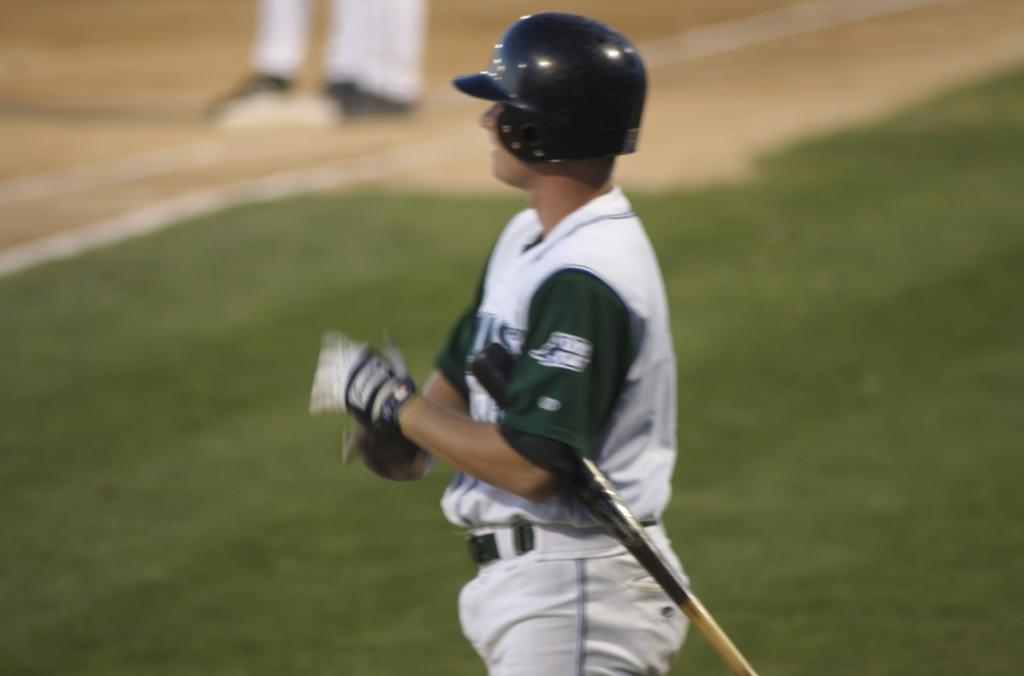What is the main subject of the image? There is a person in the image. What is the person doing in the image? The person is standing on the ground. What is the person wearing on their head? The person is wearing a black helmet. What is the person wearing on their body? The person is wearing a white dress. What is the person wearing on their hands? The person is wearing gloves. What object is the person holding in the image? The person is holding a bat. What type of root can be seen growing from the person's helmet in the image? There is no root growing from the person's helmet in the image. What type of basket is the person carrying in the image? The person is not carrying a basket in the image; they are holding a bat. 